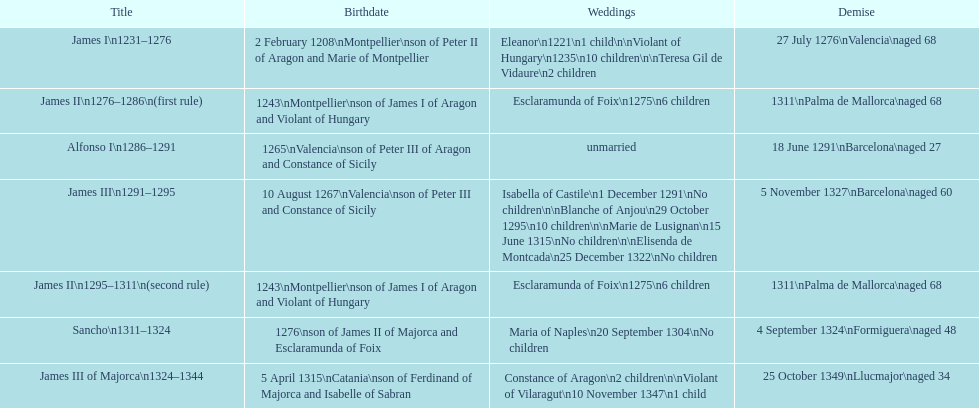How long was james ii in power, including his second rule? 26 years. 